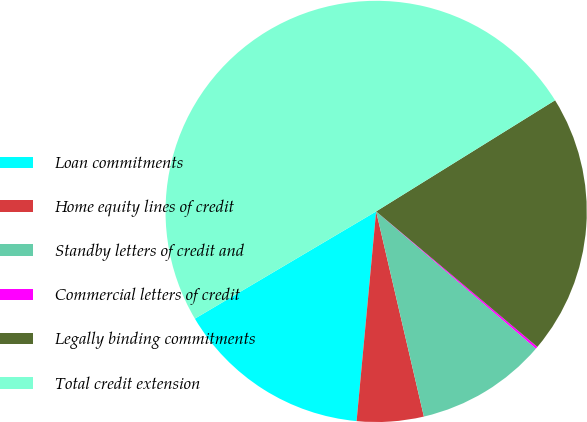<chart> <loc_0><loc_0><loc_500><loc_500><pie_chart><fcel>Loan commitments<fcel>Home equity lines of credit<fcel>Standby letters of credit and<fcel>Commercial letters of credit<fcel>Legally binding commitments<fcel>Total credit extension<nl><fcel>15.02%<fcel>5.12%<fcel>10.07%<fcel>0.17%<fcel>19.97%<fcel>49.66%<nl></chart> 